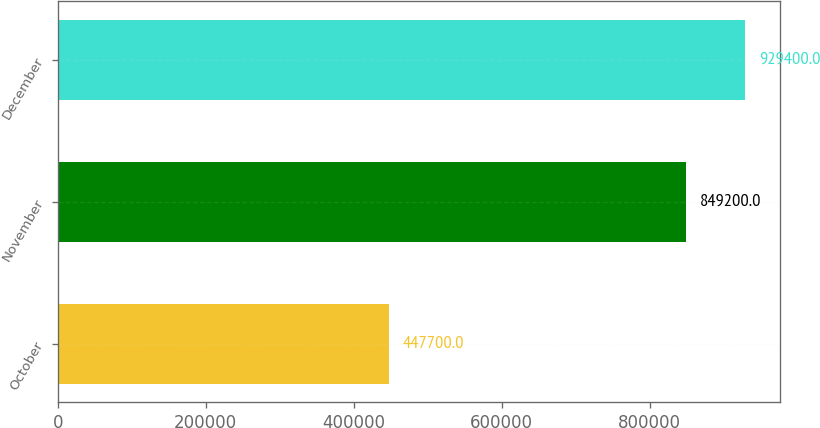Convert chart to OTSL. <chart><loc_0><loc_0><loc_500><loc_500><bar_chart><fcel>October<fcel>November<fcel>December<nl><fcel>447700<fcel>849200<fcel>929400<nl></chart> 